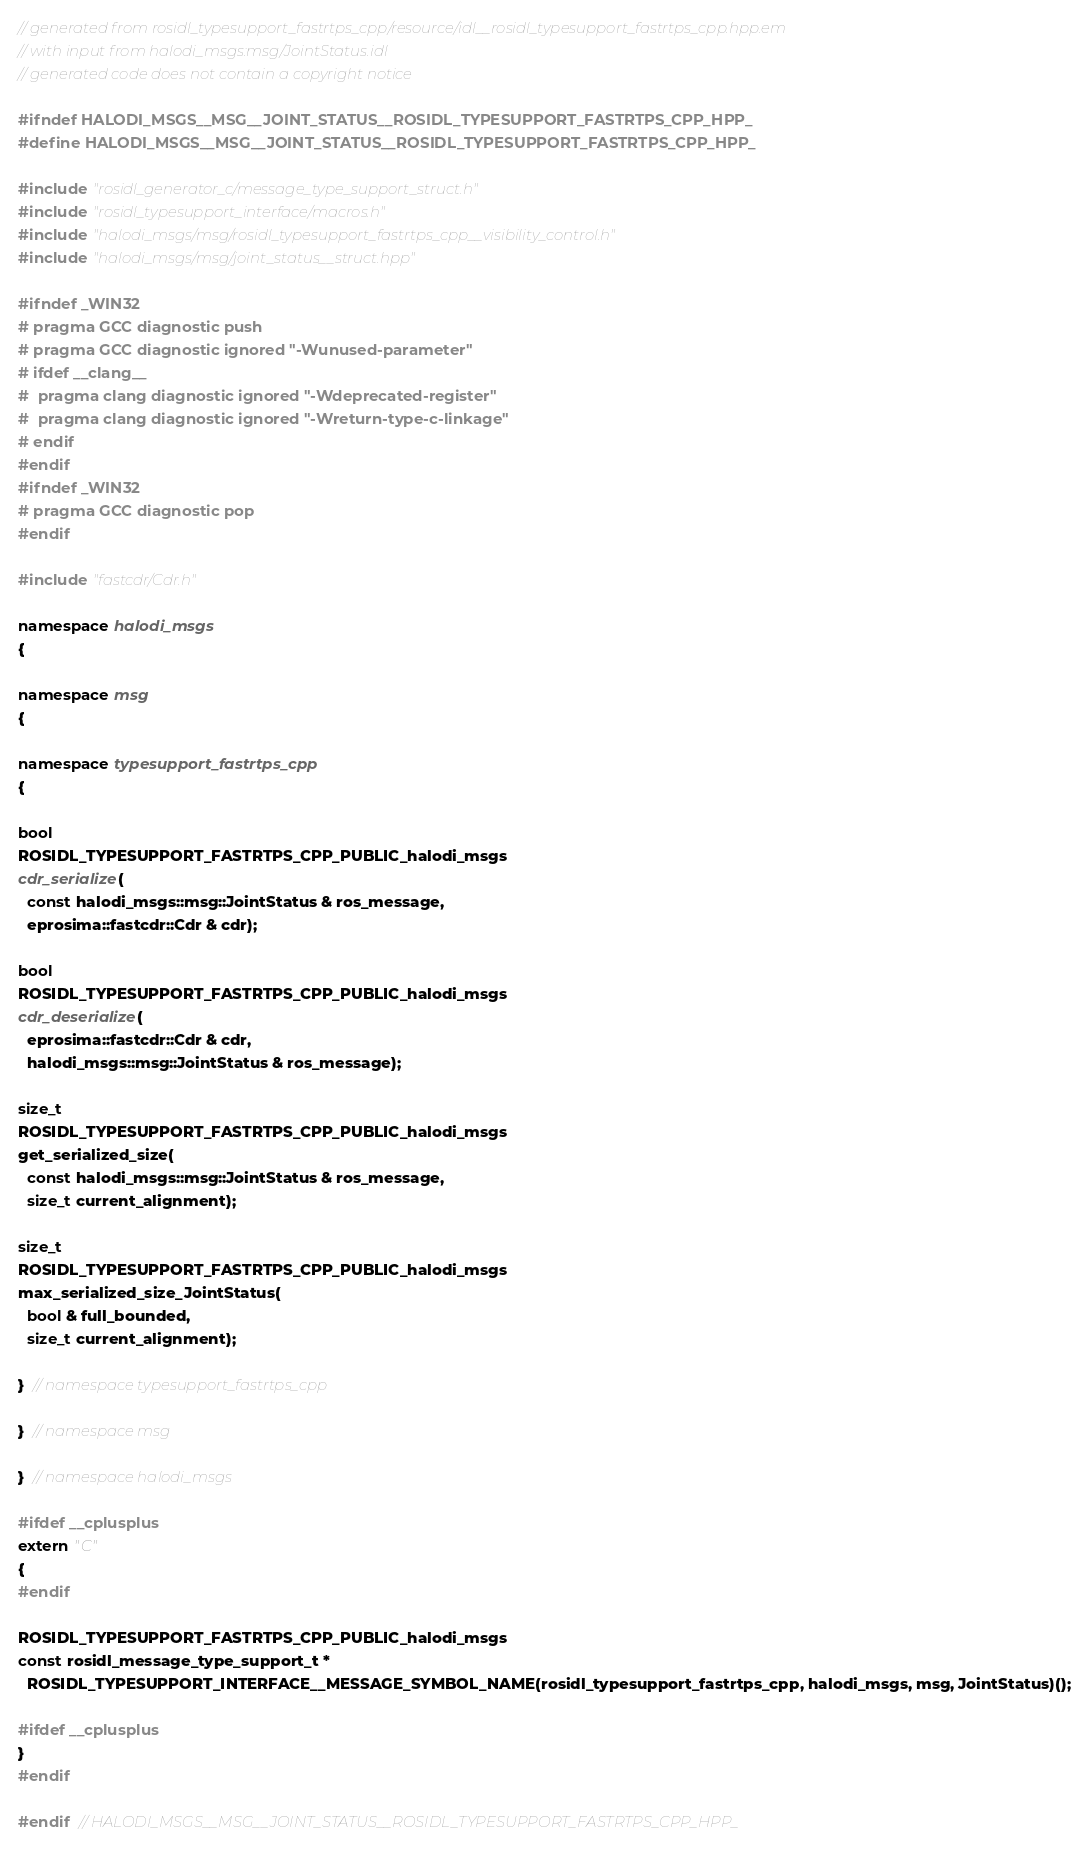<code> <loc_0><loc_0><loc_500><loc_500><_C++_>// generated from rosidl_typesupport_fastrtps_cpp/resource/idl__rosidl_typesupport_fastrtps_cpp.hpp.em
// with input from halodi_msgs:msg/JointStatus.idl
// generated code does not contain a copyright notice

#ifndef HALODI_MSGS__MSG__JOINT_STATUS__ROSIDL_TYPESUPPORT_FASTRTPS_CPP_HPP_
#define HALODI_MSGS__MSG__JOINT_STATUS__ROSIDL_TYPESUPPORT_FASTRTPS_CPP_HPP_

#include "rosidl_generator_c/message_type_support_struct.h"
#include "rosidl_typesupport_interface/macros.h"
#include "halodi_msgs/msg/rosidl_typesupport_fastrtps_cpp__visibility_control.h"
#include "halodi_msgs/msg/joint_status__struct.hpp"

#ifndef _WIN32
# pragma GCC diagnostic push
# pragma GCC diagnostic ignored "-Wunused-parameter"
# ifdef __clang__
#  pragma clang diagnostic ignored "-Wdeprecated-register"
#  pragma clang diagnostic ignored "-Wreturn-type-c-linkage"
# endif
#endif
#ifndef _WIN32
# pragma GCC diagnostic pop
#endif

#include "fastcdr/Cdr.h"

namespace halodi_msgs
{

namespace msg
{

namespace typesupport_fastrtps_cpp
{

bool
ROSIDL_TYPESUPPORT_FASTRTPS_CPP_PUBLIC_halodi_msgs
cdr_serialize(
  const halodi_msgs::msg::JointStatus & ros_message,
  eprosima::fastcdr::Cdr & cdr);

bool
ROSIDL_TYPESUPPORT_FASTRTPS_CPP_PUBLIC_halodi_msgs
cdr_deserialize(
  eprosima::fastcdr::Cdr & cdr,
  halodi_msgs::msg::JointStatus & ros_message);

size_t
ROSIDL_TYPESUPPORT_FASTRTPS_CPP_PUBLIC_halodi_msgs
get_serialized_size(
  const halodi_msgs::msg::JointStatus & ros_message,
  size_t current_alignment);

size_t
ROSIDL_TYPESUPPORT_FASTRTPS_CPP_PUBLIC_halodi_msgs
max_serialized_size_JointStatus(
  bool & full_bounded,
  size_t current_alignment);

}  // namespace typesupport_fastrtps_cpp

}  // namespace msg

}  // namespace halodi_msgs

#ifdef __cplusplus
extern "C"
{
#endif

ROSIDL_TYPESUPPORT_FASTRTPS_CPP_PUBLIC_halodi_msgs
const rosidl_message_type_support_t *
  ROSIDL_TYPESUPPORT_INTERFACE__MESSAGE_SYMBOL_NAME(rosidl_typesupport_fastrtps_cpp, halodi_msgs, msg, JointStatus)();

#ifdef __cplusplus
}
#endif

#endif  // HALODI_MSGS__MSG__JOINT_STATUS__ROSIDL_TYPESUPPORT_FASTRTPS_CPP_HPP_
</code> 